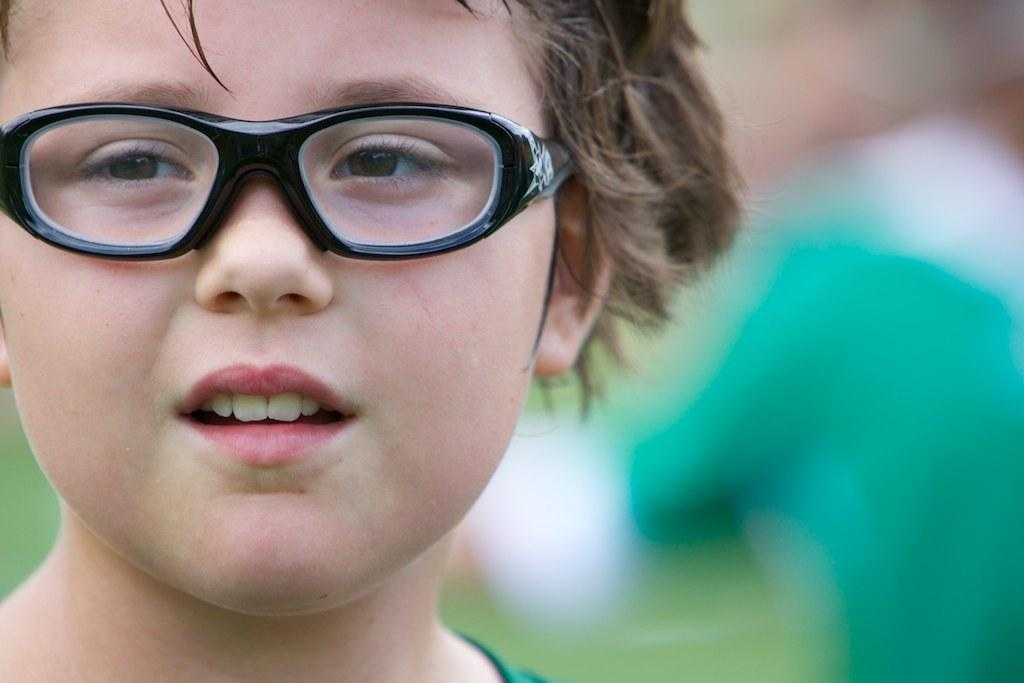What is the main subject of the image? There is a person in the image. Can you describe the person's appearance? The person is wearing specs. What can be observed about the background of the image? The background of the image is blurred. What type of sail can be seen in the image? There is no sail present in the image. How many birds are visible in the image? There are no birds visible in the image. 